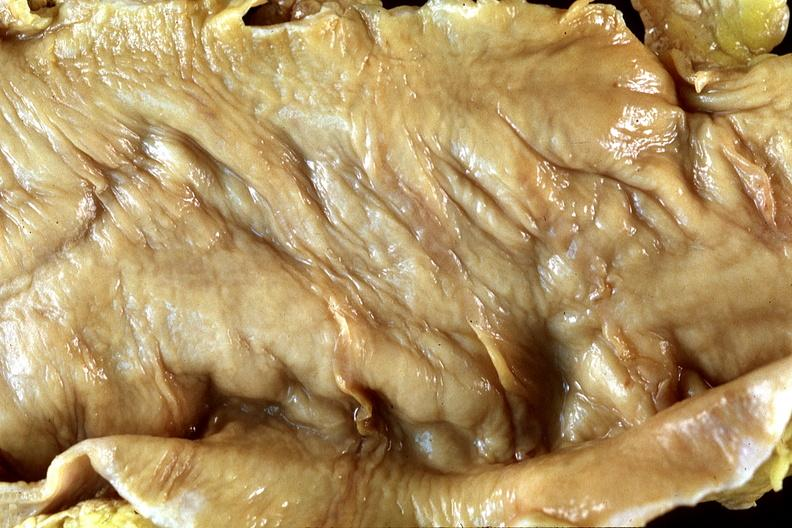does this image show normal colon?
Answer the question using a single word or phrase. Yes 